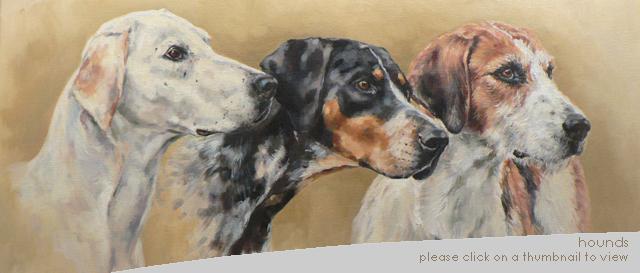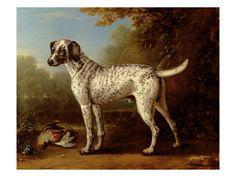The first image is the image on the left, the second image is the image on the right. Examine the images to the left and right. Is the description "One image shows multiple dogs moving forward, and the other image shows a single camera-facing hound." accurate? Answer yes or no. No. 